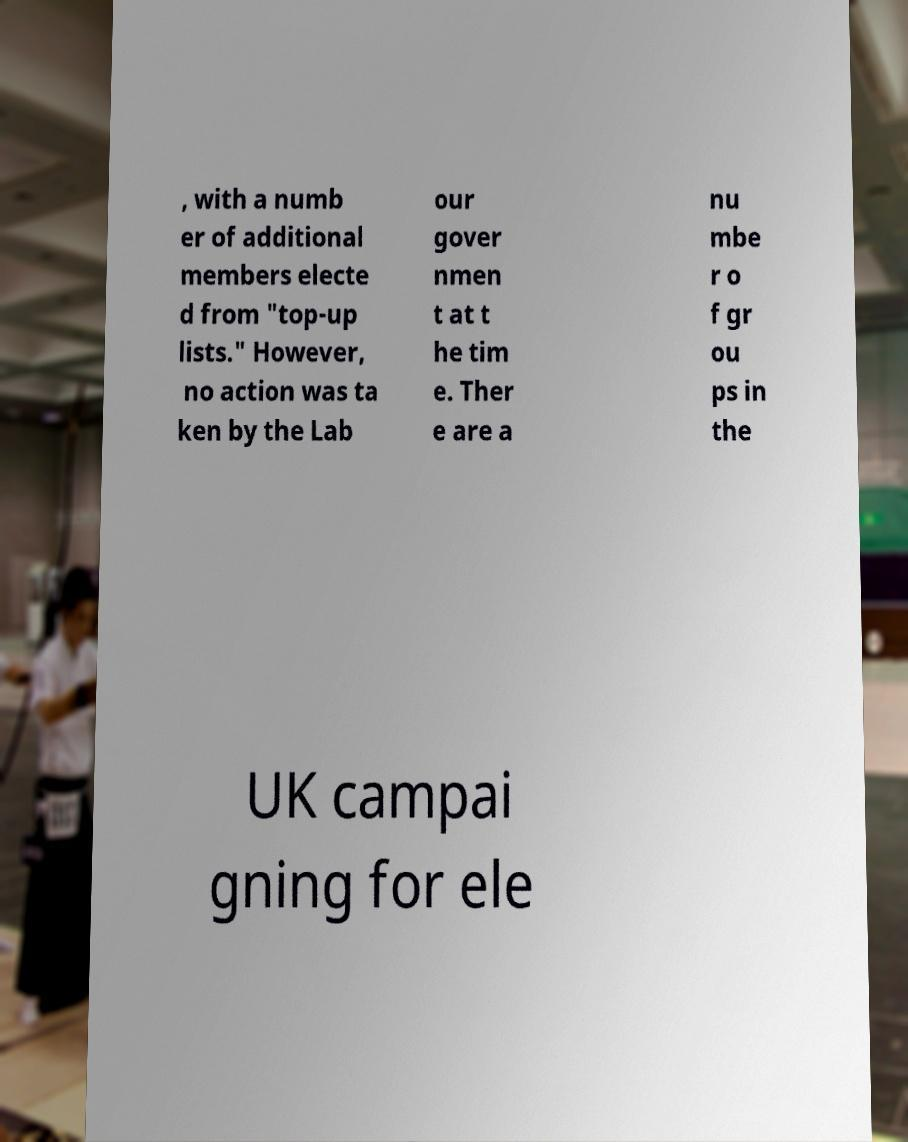Can you read and provide the text displayed in the image?This photo seems to have some interesting text. Can you extract and type it out for me? , with a numb er of additional members electe d from "top-up lists." However, no action was ta ken by the Lab our gover nmen t at t he tim e. Ther e are a nu mbe r o f gr ou ps in the UK campai gning for ele 